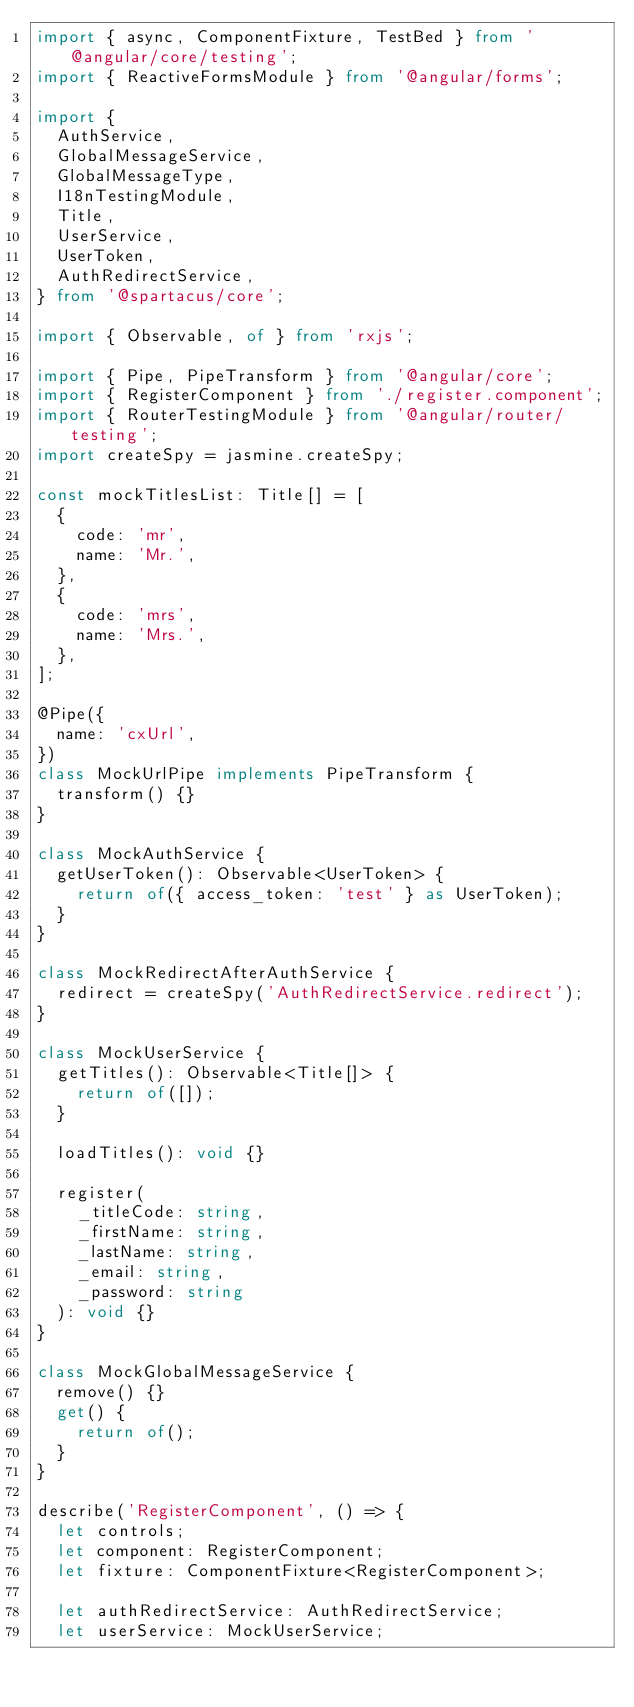<code> <loc_0><loc_0><loc_500><loc_500><_TypeScript_>import { async, ComponentFixture, TestBed } from '@angular/core/testing';
import { ReactiveFormsModule } from '@angular/forms';

import {
  AuthService,
  GlobalMessageService,
  GlobalMessageType,
  I18nTestingModule,
  Title,
  UserService,
  UserToken,
  AuthRedirectService,
} from '@spartacus/core';

import { Observable, of } from 'rxjs';

import { Pipe, PipeTransform } from '@angular/core';
import { RegisterComponent } from './register.component';
import { RouterTestingModule } from '@angular/router/testing';
import createSpy = jasmine.createSpy;

const mockTitlesList: Title[] = [
  {
    code: 'mr',
    name: 'Mr.',
  },
  {
    code: 'mrs',
    name: 'Mrs.',
  },
];

@Pipe({
  name: 'cxUrl',
})
class MockUrlPipe implements PipeTransform {
  transform() {}
}

class MockAuthService {
  getUserToken(): Observable<UserToken> {
    return of({ access_token: 'test' } as UserToken);
  }
}

class MockRedirectAfterAuthService {
  redirect = createSpy('AuthRedirectService.redirect');
}

class MockUserService {
  getTitles(): Observable<Title[]> {
    return of([]);
  }

  loadTitles(): void {}

  register(
    _titleCode: string,
    _firstName: string,
    _lastName: string,
    _email: string,
    _password: string
  ): void {}
}

class MockGlobalMessageService {
  remove() {}
  get() {
    return of();
  }
}

describe('RegisterComponent', () => {
  let controls;
  let component: RegisterComponent;
  let fixture: ComponentFixture<RegisterComponent>;

  let authRedirectService: AuthRedirectService;
  let userService: MockUserService;</code> 